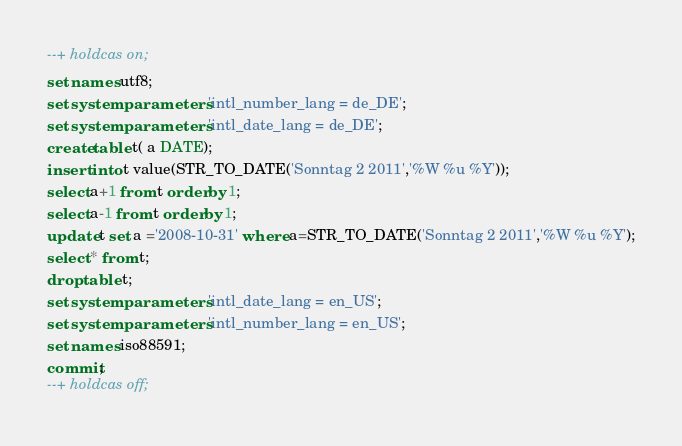Convert code to text. <code><loc_0><loc_0><loc_500><loc_500><_SQL_>--+ holdcas on;
set names utf8;
set system parameters 'intl_number_lang = de_DE';
set system parameters 'intl_date_lang = de_DE';
create table t( a DATE);
insert into t value(STR_TO_DATE('Sonntag 2 2011','%W %u %Y'));
select a+1 from t order by 1;
select a-1 from t order by 1;
update t set a ='2008-10-31' where a=STR_TO_DATE('Sonntag 2 2011','%W %u %Y');
select * from t;
drop table t;
set system parameters 'intl_date_lang = en_US';
set system parameters 'intl_number_lang = en_US';
set names iso88591;
commit;
--+ holdcas off;</code> 